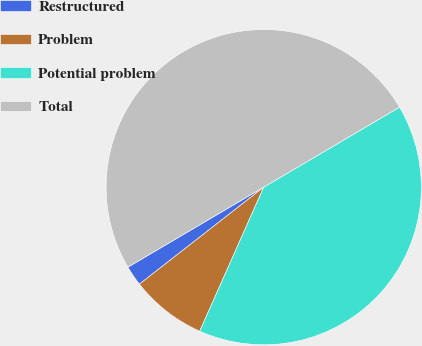Convert chart to OTSL. <chart><loc_0><loc_0><loc_500><loc_500><pie_chart><fcel>Restructured<fcel>Problem<fcel>Potential problem<fcel>Total<nl><fcel>2.07%<fcel>7.8%<fcel>40.13%<fcel>50.0%<nl></chart> 